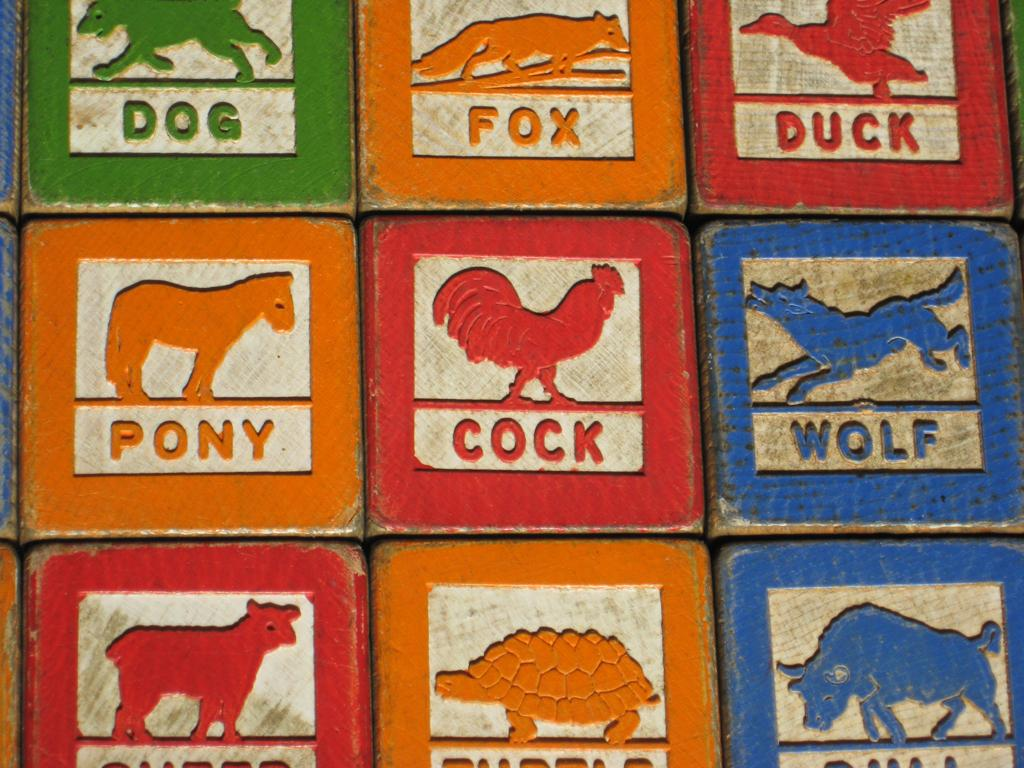What objects are present in the image? There are boxes in the image. What is depicted on the boxes? There are pictures of animals and birds on the boxes. What type of clouds can be seen on the boxes in the image? There are no clouds depicted on the boxes in the image; only pictures of animals and birds are present. 